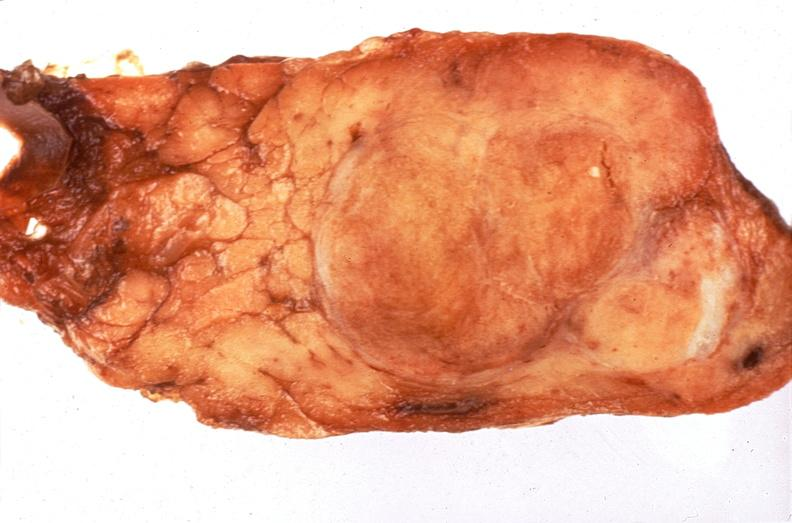does stillborn macerated show pituitary, chromaphobe adenoma?
Answer the question using a single word or phrase. No 